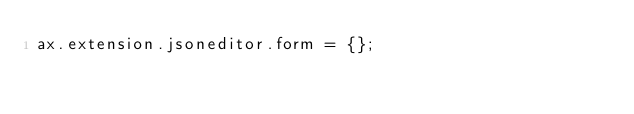<code> <loc_0><loc_0><loc_500><loc_500><_JavaScript_>ax.extension.jsoneditor.form = {};
</code> 